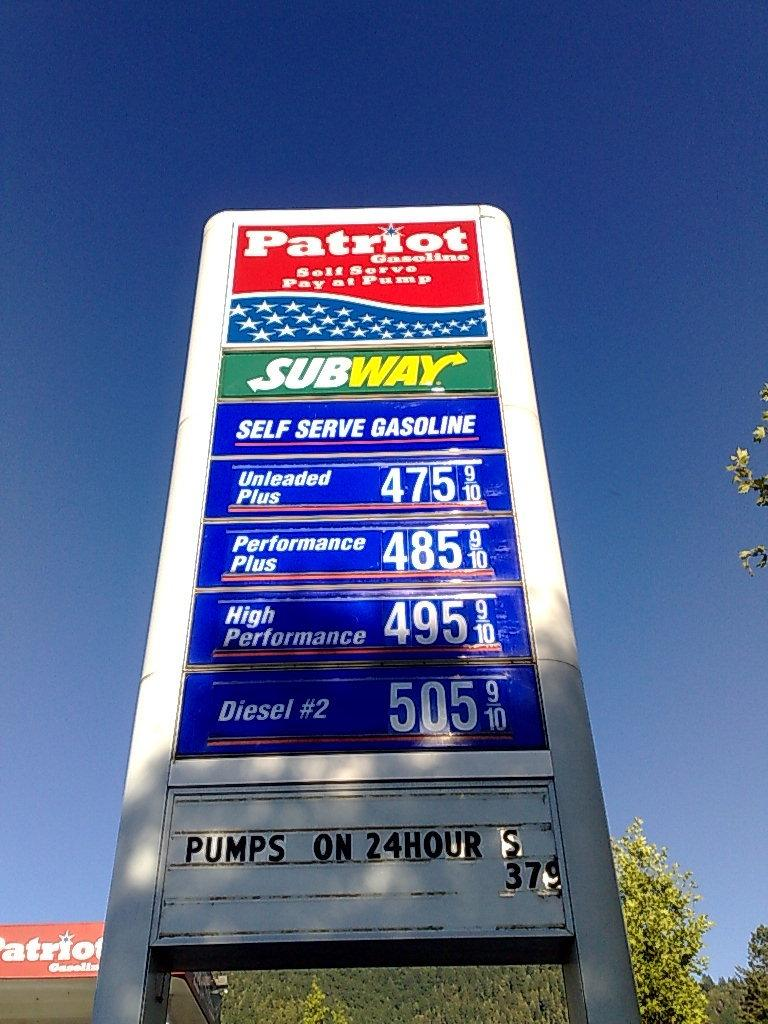Provide a one-sentence caption for the provided image. Gas sign with subway and patriot sign wrote on it. 